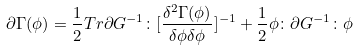<formula> <loc_0><loc_0><loc_500><loc_500>\partial \Gamma ( \phi ) = \frac { 1 } { 2 } T r \partial G ^ { - 1 } \colon [ \frac { \delta ^ { 2 } \Gamma ( \phi ) } { \delta \phi \delta \phi } ] ^ { - 1 } + \frac { 1 } { 2 } \phi \colon \partial G ^ { - 1 } \colon \phi</formula> 